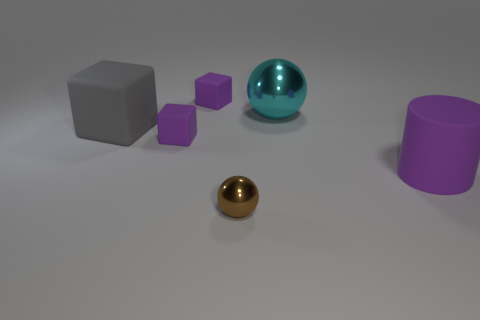Add 1 tiny purple matte cubes. How many objects exist? 7 Subtract all cylinders. How many objects are left? 5 Subtract 0 brown blocks. How many objects are left? 6 Subtract all small purple rubber objects. Subtract all big balls. How many objects are left? 3 Add 5 brown shiny spheres. How many brown shiny spheres are left? 6 Add 5 cyan metal objects. How many cyan metal objects exist? 6 